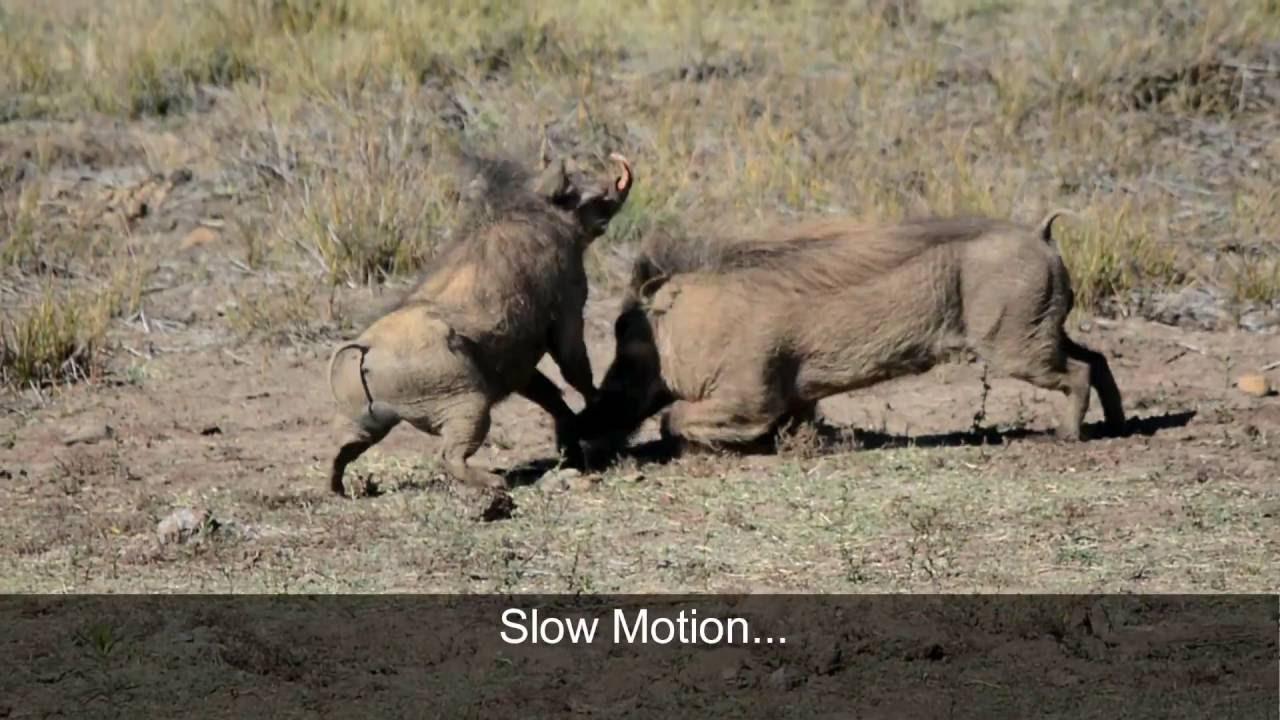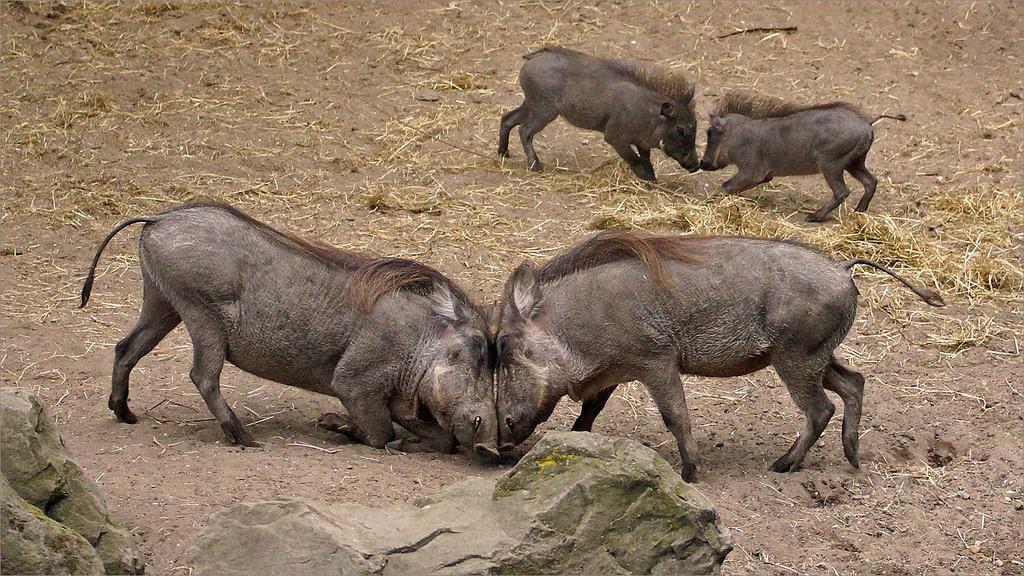The first image is the image on the left, the second image is the image on the right. Examine the images to the left and right. Is the description "A warthog is fighting with a cheetah." accurate? Answer yes or no. No. The first image is the image on the left, the second image is the image on the right. Evaluate the accuracy of this statement regarding the images: "a jaguar is attacking a warthog". Is it true? Answer yes or no. No. 